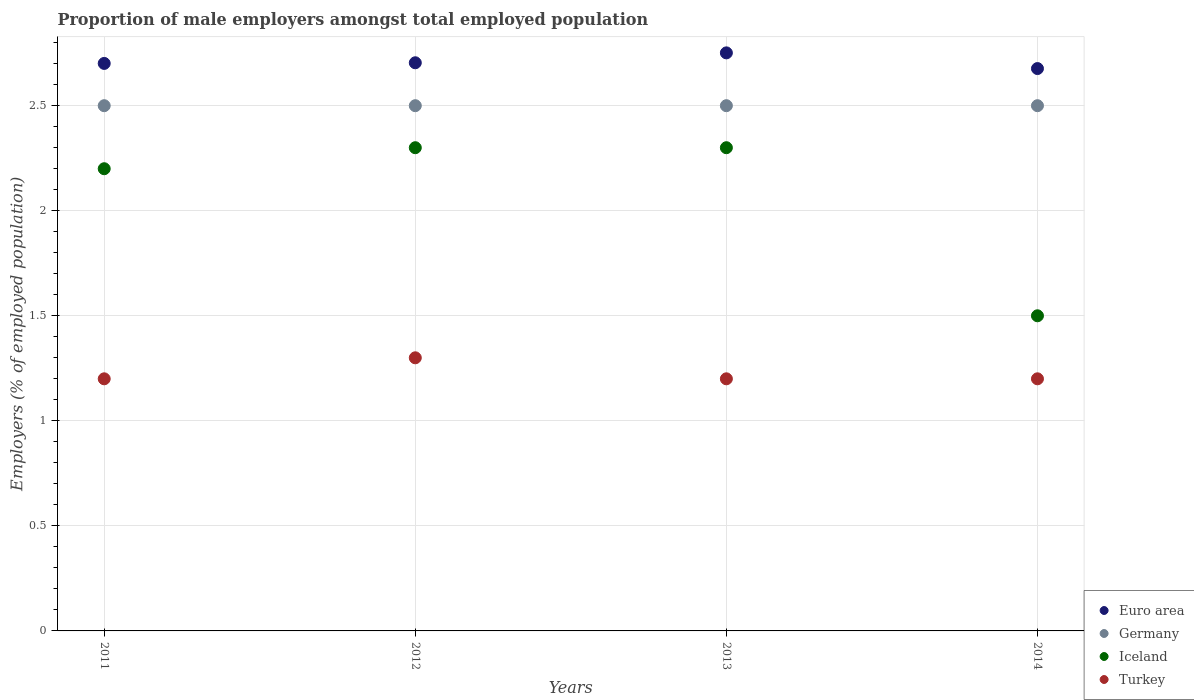How many different coloured dotlines are there?
Offer a terse response. 4. Is the number of dotlines equal to the number of legend labels?
Offer a terse response. Yes. Across all years, what is the maximum proportion of male employers in Turkey?
Your answer should be compact. 1.3. Across all years, what is the minimum proportion of male employers in Germany?
Make the answer very short. 2.5. In which year was the proportion of male employers in Germany minimum?
Your answer should be compact. 2011. What is the total proportion of male employers in Iceland in the graph?
Keep it short and to the point. 8.3. What is the difference between the proportion of male employers in Turkey in 2012 and that in 2014?
Your response must be concise. 0.1. What is the difference between the proportion of male employers in Turkey in 2011 and the proportion of male employers in Iceland in 2013?
Your answer should be very brief. -1.1. What is the average proportion of male employers in Turkey per year?
Provide a succinct answer. 1.23. In the year 2012, what is the difference between the proportion of male employers in Euro area and proportion of male employers in Iceland?
Offer a very short reply. 0.4. What is the ratio of the proportion of male employers in Iceland in 2011 to that in 2013?
Ensure brevity in your answer.  0.96. Is the proportion of male employers in Turkey in 2012 less than that in 2013?
Your answer should be compact. No. Is the difference between the proportion of male employers in Euro area in 2012 and 2013 greater than the difference between the proportion of male employers in Iceland in 2012 and 2013?
Ensure brevity in your answer.  No. What is the difference between the highest and the lowest proportion of male employers in Turkey?
Offer a terse response. 0.1. Is the sum of the proportion of male employers in Germany in 2013 and 2014 greater than the maximum proportion of male employers in Turkey across all years?
Give a very brief answer. Yes. Is it the case that in every year, the sum of the proportion of male employers in Turkey and proportion of male employers in Euro area  is greater than the proportion of male employers in Germany?
Provide a short and direct response. Yes. Is the proportion of male employers in Turkey strictly greater than the proportion of male employers in Euro area over the years?
Offer a very short reply. No. Is the proportion of male employers in Turkey strictly less than the proportion of male employers in Germany over the years?
Your answer should be compact. Yes. How many dotlines are there?
Provide a succinct answer. 4. What is the difference between two consecutive major ticks on the Y-axis?
Offer a very short reply. 0.5. Are the values on the major ticks of Y-axis written in scientific E-notation?
Provide a short and direct response. No. Does the graph contain grids?
Provide a short and direct response. Yes. Where does the legend appear in the graph?
Provide a succinct answer. Bottom right. How many legend labels are there?
Make the answer very short. 4. How are the legend labels stacked?
Your answer should be compact. Vertical. What is the title of the graph?
Provide a short and direct response. Proportion of male employers amongst total employed population. What is the label or title of the Y-axis?
Offer a terse response. Employers (% of employed population). What is the Employers (% of employed population) of Euro area in 2011?
Your answer should be very brief. 2.7. What is the Employers (% of employed population) in Germany in 2011?
Keep it short and to the point. 2.5. What is the Employers (% of employed population) in Iceland in 2011?
Make the answer very short. 2.2. What is the Employers (% of employed population) in Turkey in 2011?
Ensure brevity in your answer.  1.2. What is the Employers (% of employed population) in Euro area in 2012?
Offer a very short reply. 2.7. What is the Employers (% of employed population) of Iceland in 2012?
Keep it short and to the point. 2.3. What is the Employers (% of employed population) in Turkey in 2012?
Offer a terse response. 1.3. What is the Employers (% of employed population) of Euro area in 2013?
Offer a very short reply. 2.75. What is the Employers (% of employed population) of Iceland in 2013?
Your answer should be very brief. 2.3. What is the Employers (% of employed population) of Turkey in 2013?
Offer a terse response. 1.2. What is the Employers (% of employed population) of Euro area in 2014?
Ensure brevity in your answer.  2.68. What is the Employers (% of employed population) of Germany in 2014?
Your response must be concise. 2.5. What is the Employers (% of employed population) of Iceland in 2014?
Offer a terse response. 1.5. What is the Employers (% of employed population) in Turkey in 2014?
Ensure brevity in your answer.  1.2. Across all years, what is the maximum Employers (% of employed population) of Euro area?
Your answer should be compact. 2.75. Across all years, what is the maximum Employers (% of employed population) in Iceland?
Offer a terse response. 2.3. Across all years, what is the maximum Employers (% of employed population) in Turkey?
Keep it short and to the point. 1.3. Across all years, what is the minimum Employers (% of employed population) of Euro area?
Keep it short and to the point. 2.68. Across all years, what is the minimum Employers (% of employed population) of Turkey?
Offer a terse response. 1.2. What is the total Employers (% of employed population) of Euro area in the graph?
Your answer should be very brief. 10.83. What is the total Employers (% of employed population) of Germany in the graph?
Give a very brief answer. 10. What is the total Employers (% of employed population) of Iceland in the graph?
Offer a very short reply. 8.3. What is the difference between the Employers (% of employed population) of Euro area in 2011 and that in 2012?
Offer a very short reply. -0. What is the difference between the Employers (% of employed population) in Iceland in 2011 and that in 2012?
Provide a short and direct response. -0.1. What is the difference between the Employers (% of employed population) in Euro area in 2011 and that in 2013?
Your answer should be very brief. -0.05. What is the difference between the Employers (% of employed population) of Iceland in 2011 and that in 2013?
Offer a terse response. -0.1. What is the difference between the Employers (% of employed population) of Turkey in 2011 and that in 2013?
Provide a succinct answer. 0. What is the difference between the Employers (% of employed population) in Euro area in 2011 and that in 2014?
Offer a very short reply. 0.02. What is the difference between the Employers (% of employed population) of Germany in 2011 and that in 2014?
Ensure brevity in your answer.  0. What is the difference between the Employers (% of employed population) in Turkey in 2011 and that in 2014?
Give a very brief answer. 0. What is the difference between the Employers (% of employed population) of Euro area in 2012 and that in 2013?
Your answer should be very brief. -0.05. What is the difference between the Employers (% of employed population) in Turkey in 2012 and that in 2013?
Make the answer very short. 0.1. What is the difference between the Employers (% of employed population) of Euro area in 2012 and that in 2014?
Make the answer very short. 0.03. What is the difference between the Employers (% of employed population) in Germany in 2012 and that in 2014?
Offer a very short reply. 0. What is the difference between the Employers (% of employed population) in Euro area in 2013 and that in 2014?
Provide a short and direct response. 0.07. What is the difference between the Employers (% of employed population) in Germany in 2013 and that in 2014?
Make the answer very short. 0. What is the difference between the Employers (% of employed population) of Iceland in 2013 and that in 2014?
Your answer should be very brief. 0.8. What is the difference between the Employers (% of employed population) in Euro area in 2011 and the Employers (% of employed population) in Germany in 2012?
Your answer should be compact. 0.2. What is the difference between the Employers (% of employed population) in Euro area in 2011 and the Employers (% of employed population) in Iceland in 2012?
Your answer should be very brief. 0.4. What is the difference between the Employers (% of employed population) in Euro area in 2011 and the Employers (% of employed population) in Turkey in 2012?
Offer a terse response. 1.4. What is the difference between the Employers (% of employed population) in Germany in 2011 and the Employers (% of employed population) in Turkey in 2012?
Give a very brief answer. 1.2. What is the difference between the Employers (% of employed population) in Iceland in 2011 and the Employers (% of employed population) in Turkey in 2012?
Your answer should be compact. 0.9. What is the difference between the Employers (% of employed population) in Euro area in 2011 and the Employers (% of employed population) in Germany in 2013?
Make the answer very short. 0.2. What is the difference between the Employers (% of employed population) of Euro area in 2011 and the Employers (% of employed population) of Iceland in 2013?
Your answer should be compact. 0.4. What is the difference between the Employers (% of employed population) of Euro area in 2011 and the Employers (% of employed population) of Turkey in 2013?
Provide a short and direct response. 1.5. What is the difference between the Employers (% of employed population) of Germany in 2011 and the Employers (% of employed population) of Turkey in 2013?
Provide a short and direct response. 1.3. What is the difference between the Employers (% of employed population) in Euro area in 2011 and the Employers (% of employed population) in Germany in 2014?
Your answer should be compact. 0.2. What is the difference between the Employers (% of employed population) in Euro area in 2011 and the Employers (% of employed population) in Iceland in 2014?
Give a very brief answer. 1.2. What is the difference between the Employers (% of employed population) in Euro area in 2011 and the Employers (% of employed population) in Turkey in 2014?
Offer a terse response. 1.5. What is the difference between the Employers (% of employed population) of Germany in 2011 and the Employers (% of employed population) of Turkey in 2014?
Provide a succinct answer. 1.3. What is the difference between the Employers (% of employed population) of Iceland in 2011 and the Employers (% of employed population) of Turkey in 2014?
Provide a succinct answer. 1. What is the difference between the Employers (% of employed population) in Euro area in 2012 and the Employers (% of employed population) in Germany in 2013?
Provide a short and direct response. 0.2. What is the difference between the Employers (% of employed population) of Euro area in 2012 and the Employers (% of employed population) of Iceland in 2013?
Your response must be concise. 0.4. What is the difference between the Employers (% of employed population) in Euro area in 2012 and the Employers (% of employed population) in Turkey in 2013?
Ensure brevity in your answer.  1.5. What is the difference between the Employers (% of employed population) of Iceland in 2012 and the Employers (% of employed population) of Turkey in 2013?
Keep it short and to the point. 1.1. What is the difference between the Employers (% of employed population) in Euro area in 2012 and the Employers (% of employed population) in Germany in 2014?
Your answer should be compact. 0.2. What is the difference between the Employers (% of employed population) in Euro area in 2012 and the Employers (% of employed population) in Iceland in 2014?
Offer a terse response. 1.2. What is the difference between the Employers (% of employed population) in Euro area in 2012 and the Employers (% of employed population) in Turkey in 2014?
Your response must be concise. 1.5. What is the difference between the Employers (% of employed population) in Iceland in 2012 and the Employers (% of employed population) in Turkey in 2014?
Your response must be concise. 1.1. What is the difference between the Employers (% of employed population) in Euro area in 2013 and the Employers (% of employed population) in Germany in 2014?
Keep it short and to the point. 0.25. What is the difference between the Employers (% of employed population) in Euro area in 2013 and the Employers (% of employed population) in Iceland in 2014?
Offer a terse response. 1.25. What is the difference between the Employers (% of employed population) of Euro area in 2013 and the Employers (% of employed population) of Turkey in 2014?
Your answer should be very brief. 1.55. What is the difference between the Employers (% of employed population) in Iceland in 2013 and the Employers (% of employed population) in Turkey in 2014?
Your response must be concise. 1.1. What is the average Employers (% of employed population) in Euro area per year?
Ensure brevity in your answer.  2.71. What is the average Employers (% of employed population) in Iceland per year?
Keep it short and to the point. 2.08. What is the average Employers (% of employed population) in Turkey per year?
Your response must be concise. 1.23. In the year 2011, what is the difference between the Employers (% of employed population) of Euro area and Employers (% of employed population) of Germany?
Offer a very short reply. 0.2. In the year 2011, what is the difference between the Employers (% of employed population) in Euro area and Employers (% of employed population) in Iceland?
Keep it short and to the point. 0.5. In the year 2011, what is the difference between the Employers (% of employed population) of Euro area and Employers (% of employed population) of Turkey?
Make the answer very short. 1.5. In the year 2011, what is the difference between the Employers (% of employed population) in Germany and Employers (% of employed population) in Iceland?
Provide a short and direct response. 0.3. In the year 2011, what is the difference between the Employers (% of employed population) of Germany and Employers (% of employed population) of Turkey?
Give a very brief answer. 1.3. In the year 2012, what is the difference between the Employers (% of employed population) in Euro area and Employers (% of employed population) in Germany?
Your answer should be very brief. 0.2. In the year 2012, what is the difference between the Employers (% of employed population) of Euro area and Employers (% of employed population) of Iceland?
Your response must be concise. 0.4. In the year 2012, what is the difference between the Employers (% of employed population) of Euro area and Employers (% of employed population) of Turkey?
Keep it short and to the point. 1.4. In the year 2012, what is the difference between the Employers (% of employed population) in Iceland and Employers (% of employed population) in Turkey?
Ensure brevity in your answer.  1. In the year 2013, what is the difference between the Employers (% of employed population) in Euro area and Employers (% of employed population) in Germany?
Your answer should be compact. 0.25. In the year 2013, what is the difference between the Employers (% of employed population) in Euro area and Employers (% of employed population) in Iceland?
Keep it short and to the point. 0.45. In the year 2013, what is the difference between the Employers (% of employed population) of Euro area and Employers (% of employed population) of Turkey?
Your answer should be compact. 1.55. In the year 2013, what is the difference between the Employers (% of employed population) of Iceland and Employers (% of employed population) of Turkey?
Your response must be concise. 1.1. In the year 2014, what is the difference between the Employers (% of employed population) of Euro area and Employers (% of employed population) of Germany?
Make the answer very short. 0.18. In the year 2014, what is the difference between the Employers (% of employed population) of Euro area and Employers (% of employed population) of Iceland?
Keep it short and to the point. 1.18. In the year 2014, what is the difference between the Employers (% of employed population) of Euro area and Employers (% of employed population) of Turkey?
Offer a terse response. 1.48. What is the ratio of the Employers (% of employed population) of Euro area in 2011 to that in 2012?
Provide a short and direct response. 1. What is the ratio of the Employers (% of employed population) in Iceland in 2011 to that in 2012?
Your answer should be compact. 0.96. What is the ratio of the Employers (% of employed population) of Turkey in 2011 to that in 2012?
Provide a succinct answer. 0.92. What is the ratio of the Employers (% of employed population) in Euro area in 2011 to that in 2013?
Make the answer very short. 0.98. What is the ratio of the Employers (% of employed population) in Iceland in 2011 to that in 2013?
Your answer should be very brief. 0.96. What is the ratio of the Employers (% of employed population) in Turkey in 2011 to that in 2013?
Your response must be concise. 1. What is the ratio of the Employers (% of employed population) of Euro area in 2011 to that in 2014?
Your answer should be very brief. 1.01. What is the ratio of the Employers (% of employed population) of Iceland in 2011 to that in 2014?
Offer a very short reply. 1.47. What is the ratio of the Employers (% of employed population) of Euro area in 2012 to that in 2013?
Offer a terse response. 0.98. What is the ratio of the Employers (% of employed population) of Germany in 2012 to that in 2013?
Keep it short and to the point. 1. What is the ratio of the Employers (% of employed population) in Turkey in 2012 to that in 2013?
Ensure brevity in your answer.  1.08. What is the ratio of the Employers (% of employed population) of Euro area in 2012 to that in 2014?
Offer a very short reply. 1.01. What is the ratio of the Employers (% of employed population) in Germany in 2012 to that in 2014?
Offer a very short reply. 1. What is the ratio of the Employers (% of employed population) of Iceland in 2012 to that in 2014?
Your answer should be very brief. 1.53. What is the ratio of the Employers (% of employed population) of Euro area in 2013 to that in 2014?
Ensure brevity in your answer.  1.03. What is the ratio of the Employers (% of employed population) of Iceland in 2013 to that in 2014?
Provide a succinct answer. 1.53. What is the ratio of the Employers (% of employed population) in Turkey in 2013 to that in 2014?
Ensure brevity in your answer.  1. What is the difference between the highest and the second highest Employers (% of employed population) of Euro area?
Your answer should be very brief. 0.05. What is the difference between the highest and the second highest Employers (% of employed population) in Turkey?
Provide a short and direct response. 0.1. What is the difference between the highest and the lowest Employers (% of employed population) of Euro area?
Offer a very short reply. 0.07. What is the difference between the highest and the lowest Employers (% of employed population) in Turkey?
Provide a succinct answer. 0.1. 